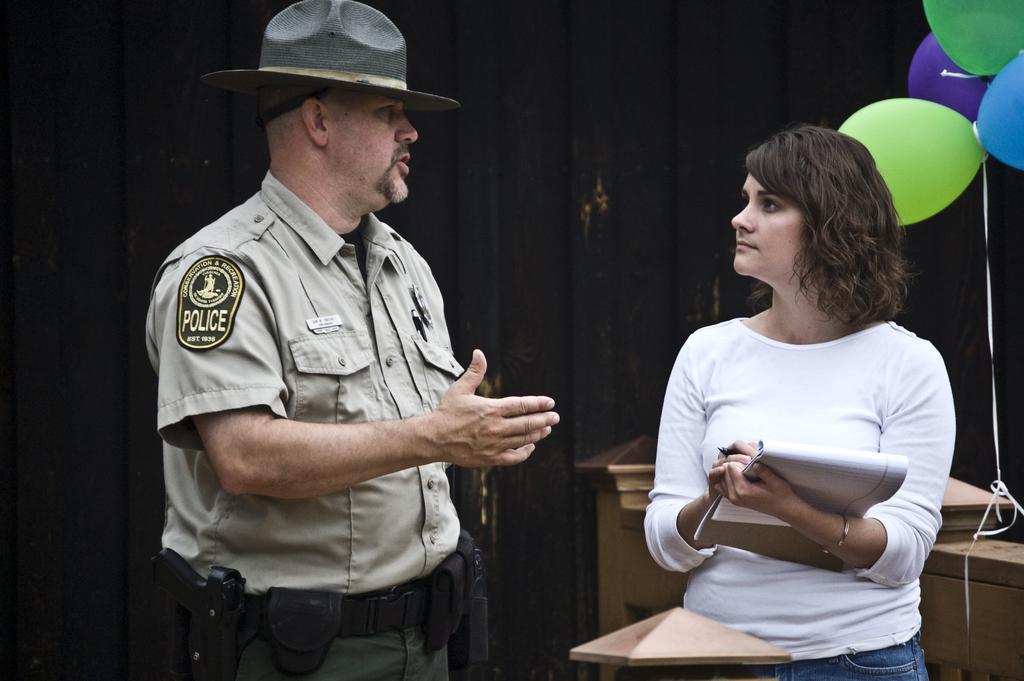Describe this image in one or two sentences. Here in this picture we can see a man and a woman standing over a place and the man is police officer, as we can see he is wearing uniform and hat on him and he is speaking something to the woman in front of him over there and the woman is trying to note down things with book and p en in hand over there and behind them we can see balloons present over a place. 